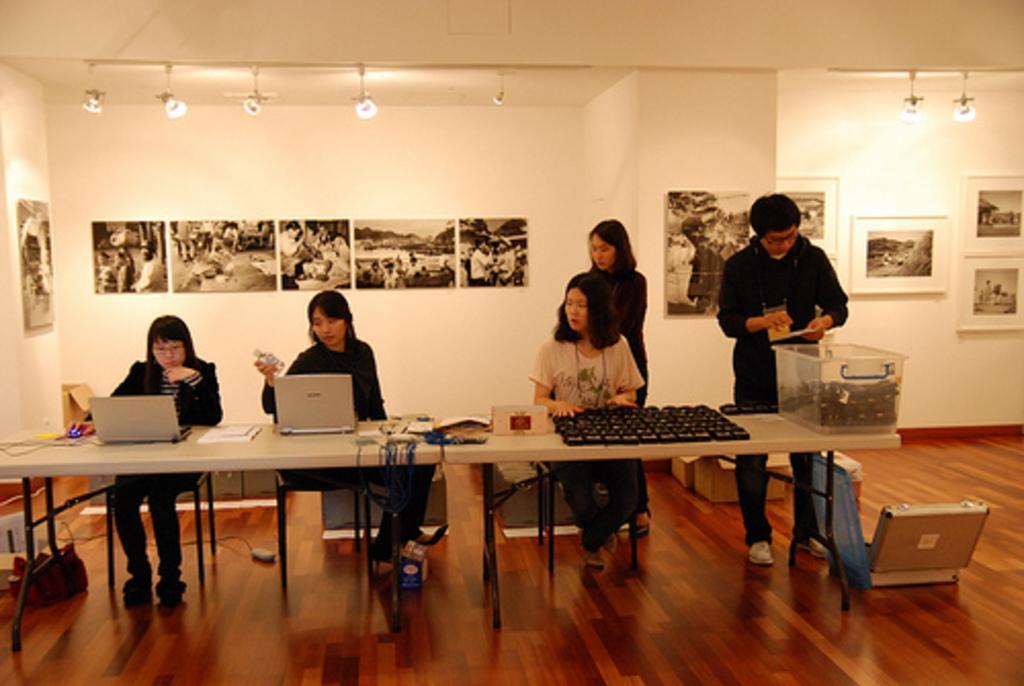Can you describe this image briefly? Here we can see three persons are sitting on the chairs. This is table. On the table there are laptops, books, and a box. Here we can see two persons are standing on the floor. On the background there is a wall and these are the frames. And there are lights. 